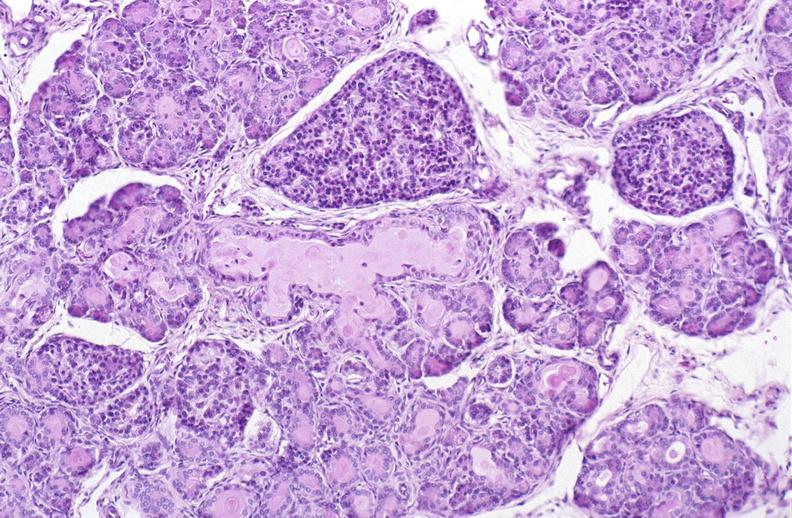what does this image show?
Answer the question using a single word or phrase. Cystic fibrosis 